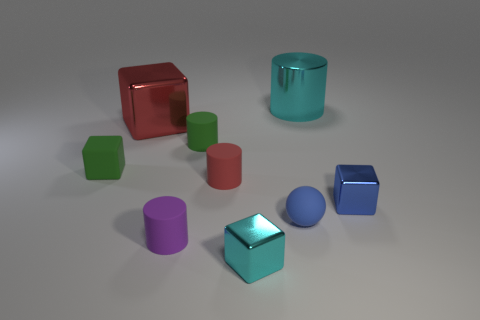What number of small blue spheres are behind the large thing right of the small rubber object that is right of the tiny red matte thing?
Your answer should be very brief. 0. What is the color of the tiny metal block that is in front of the small purple cylinder?
Your response must be concise. Cyan. What is the small block that is both left of the big cyan shiny thing and to the right of the large metal cube made of?
Your answer should be very brief. Metal. What number of large metallic things are to the right of the small green thing right of the rubber block?
Provide a succinct answer. 1. What is the shape of the large red shiny thing?
Provide a succinct answer. Cube. What shape is the tiny red thing that is made of the same material as the ball?
Your response must be concise. Cylinder. There is a large metallic thing in front of the big cylinder; is it the same shape as the tiny red object?
Give a very brief answer. No. There is a large object to the left of the tiny blue sphere; what shape is it?
Your response must be concise. Cube. There is a shiny object that is the same color as the large cylinder; what shape is it?
Make the answer very short. Cube. What number of balls are the same size as the cyan shiny cylinder?
Make the answer very short. 0. 